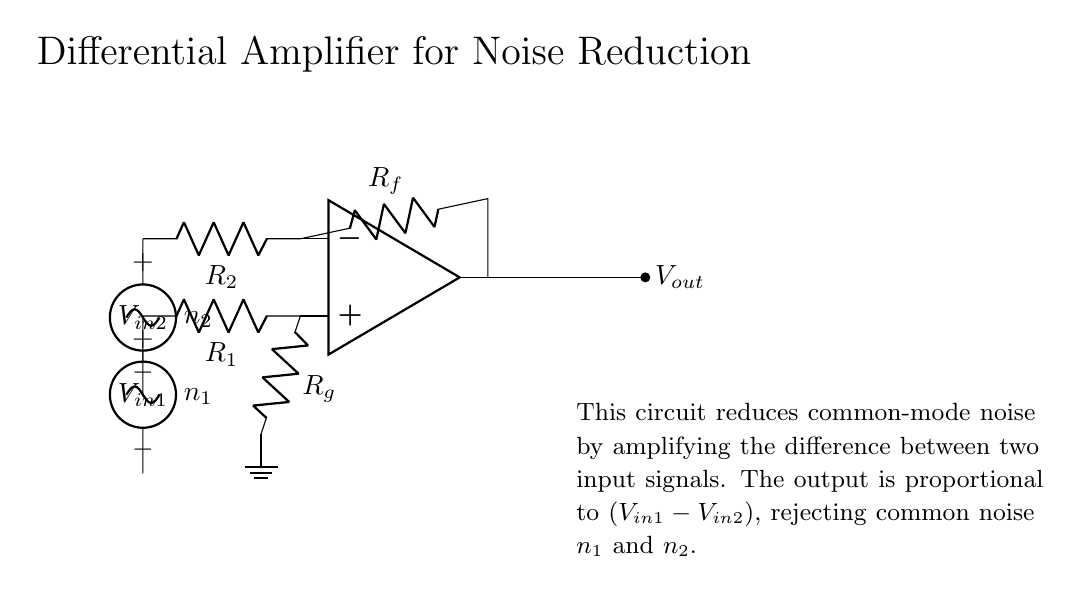What type of amplifier is shown in the circuit? The circuit is a differential amplifier that amplifies the difference between two input signals. The operational amplifier configuration specifically indicates it is used for such purposes.
Answer: Differential amplifier What are the names of the input voltage sources? The input voltage sources are labeled as V in one and V in two. These labels correspond to the two input signals that the differential amplifier processes.
Answer: V in one, V in two What is the purpose of resistor R f in the circuit? Resistor R f is a feedback resistor that helps determine the gain of the amplifier. Feedback resistors are essential in stabilizing the circuit and controlling the output signal.
Answer: Gain control How does this circuit reduce common-mode noise? The circuit reduces common-mode noise by amplifying only the difference between the two input signals while rejecting the noise that is common to both inputs. This is due to the differential nature of the amplifier's design.
Answer: Rejects common-mode noise What is the output voltage V out proportional to? The output voltage V out is proportional to the difference between the input voltages: (V in one - V in two). This relationship defines how the output voltage changes based on the input signals.
Answer: V in one - V in two What kind of noise sources are present in the circuit? The noise sources present are labeled as n one and n two, indicating that they are sinusoidal voltage sources added to the input signals to simulate noise affecting both channels.
Answer: Sinusoidal voltage sources What happens if R g is increased in this circuit? Increasing R g impacts the gain of the amplifier, potentially reducing it, as resistance values influence how much the input difference is amplified at the output. This change modifies the sensitivity of the circuit to the input signals.
Answer: Decreases gain 